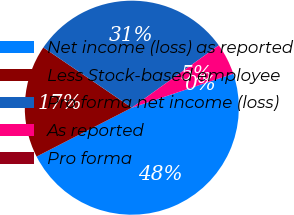Convert chart to OTSL. <chart><loc_0><loc_0><loc_500><loc_500><pie_chart><fcel>Net income (loss) as reported<fcel>Less Stock-based employee<fcel>Pro forma net income (loss)<fcel>As reported<fcel>Pro forma<nl><fcel>47.6%<fcel>17.06%<fcel>30.59%<fcel>4.76%<fcel>0.0%<nl></chart> 